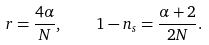<formula> <loc_0><loc_0><loc_500><loc_500>r = \frac { 4 \alpha } { N } , \quad 1 - n _ { s } = \frac { \alpha + 2 } { 2 N } .</formula> 